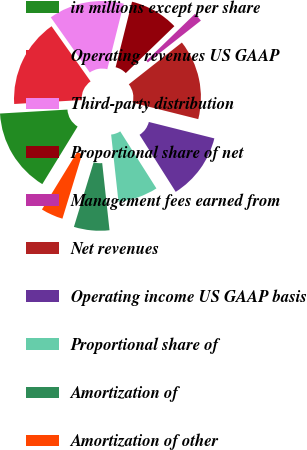Convert chart. <chart><loc_0><loc_0><loc_500><loc_500><pie_chart><fcel>in millions except per share<fcel>Operating revenues US GAAP<fcel>Third-party distribution<fcel>Proportional share of net<fcel>Management fees earned from<fcel>Net revenues<fcel>Operating income US GAAP basis<fcel>Proportional share of<fcel>Amortization of<fcel>Amortization of other<nl><fcel>15.32%<fcel>16.13%<fcel>13.71%<fcel>8.87%<fcel>1.61%<fcel>14.52%<fcel>12.1%<fcel>7.26%<fcel>6.45%<fcel>4.03%<nl></chart> 